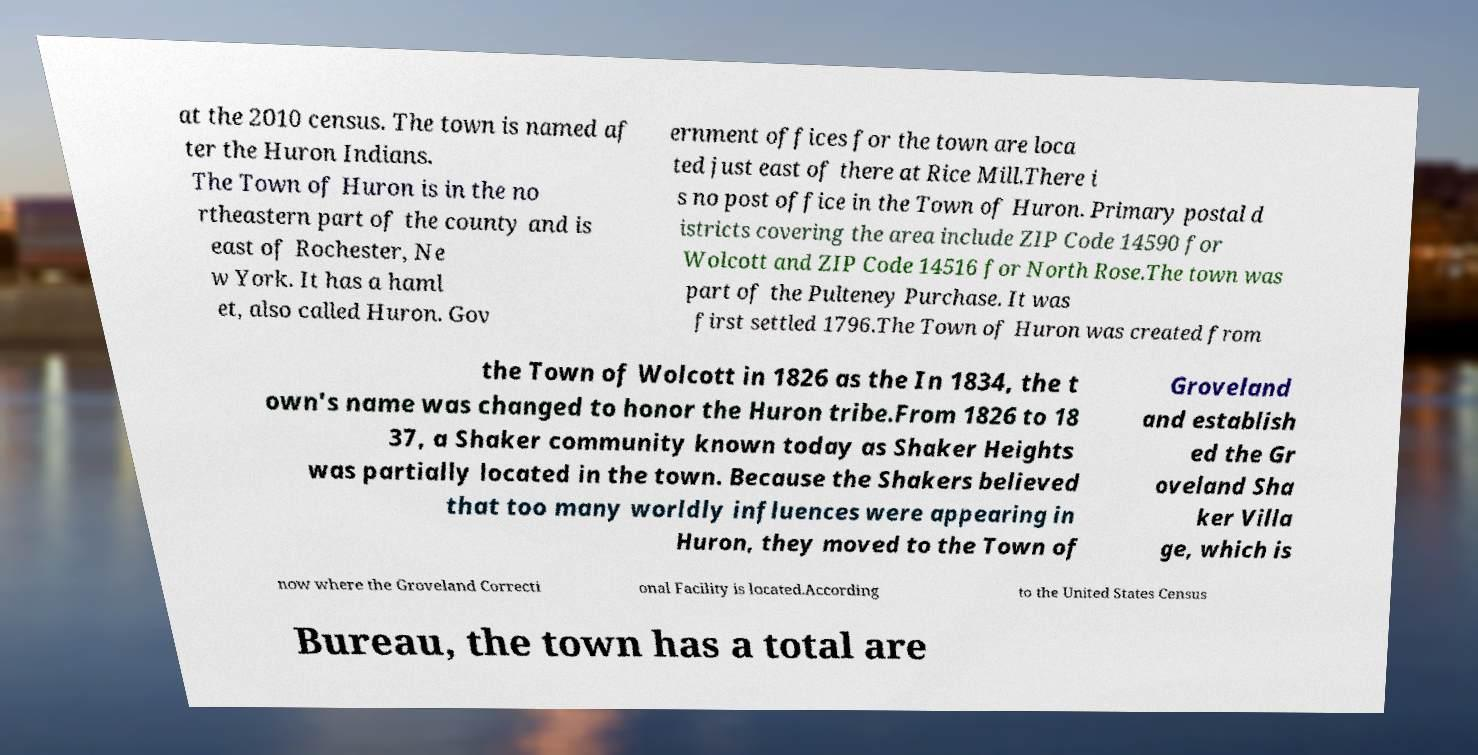Please identify and transcribe the text found in this image. at the 2010 census. The town is named af ter the Huron Indians. The Town of Huron is in the no rtheastern part of the county and is east of Rochester, Ne w York. It has a haml et, also called Huron. Gov ernment offices for the town are loca ted just east of there at Rice Mill.There i s no post office in the Town of Huron. Primary postal d istricts covering the area include ZIP Code 14590 for Wolcott and ZIP Code 14516 for North Rose.The town was part of the Pulteney Purchase. It was first settled 1796.The Town of Huron was created from the Town of Wolcott in 1826 as the In 1834, the t own's name was changed to honor the Huron tribe.From 1826 to 18 37, a Shaker community known today as Shaker Heights was partially located in the town. Because the Shakers believed that too many worldly influences were appearing in Huron, they moved to the Town of Groveland and establish ed the Gr oveland Sha ker Villa ge, which is now where the Groveland Correcti onal Facility is located.According to the United States Census Bureau, the town has a total are 